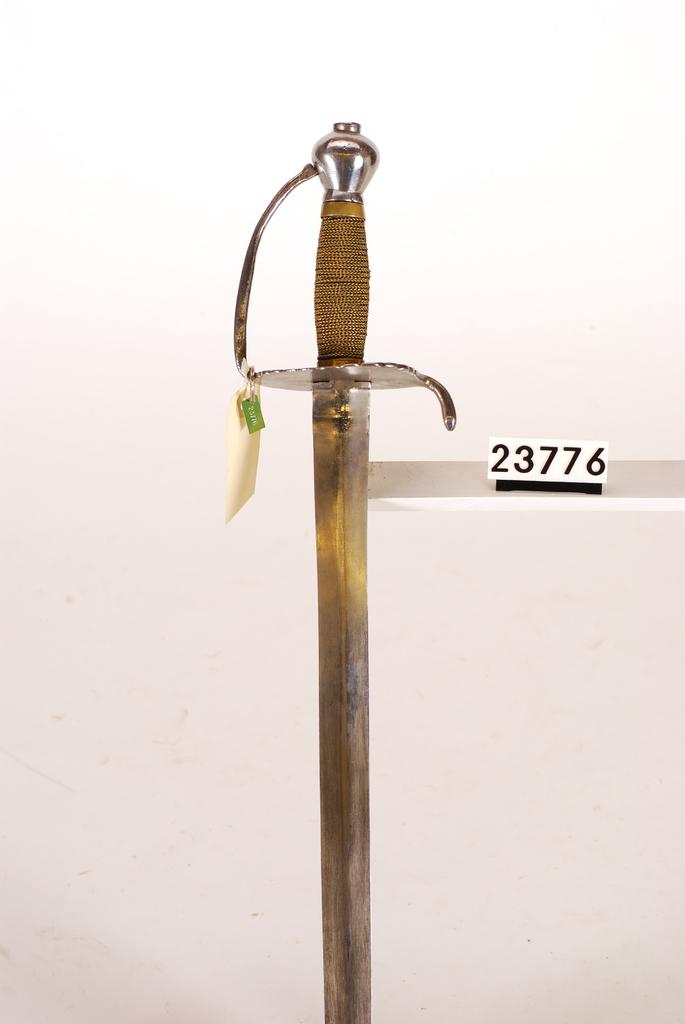What object can be seen in the image that is typically used as a weapon? There is a sword in the image. What type of paper is present in the image, and what is written on it? There is a white paper with numbers written on it in the image. What color is the background of the image? The background of the image is white. Can you tell me how many lawyers are depicted in the image? There are no lawyers present in the image. Is the sword sinking in quicksand in the image? There is no quicksand present in the image, and therefore the sword is not sinking in it. 